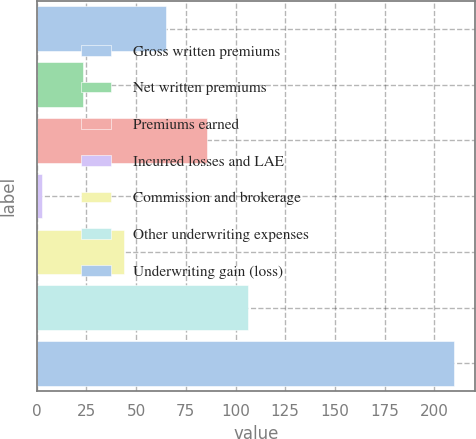<chart> <loc_0><loc_0><loc_500><loc_500><bar_chart><fcel>Gross written premiums<fcel>Net written premiums<fcel>Premiums earned<fcel>Incurred losses and LAE<fcel>Commission and brokerage<fcel>Other underwriting expenses<fcel>Underwriting gain (loss)<nl><fcel>64.92<fcel>23.44<fcel>85.66<fcel>2.7<fcel>44.18<fcel>106.4<fcel>210.1<nl></chart> 